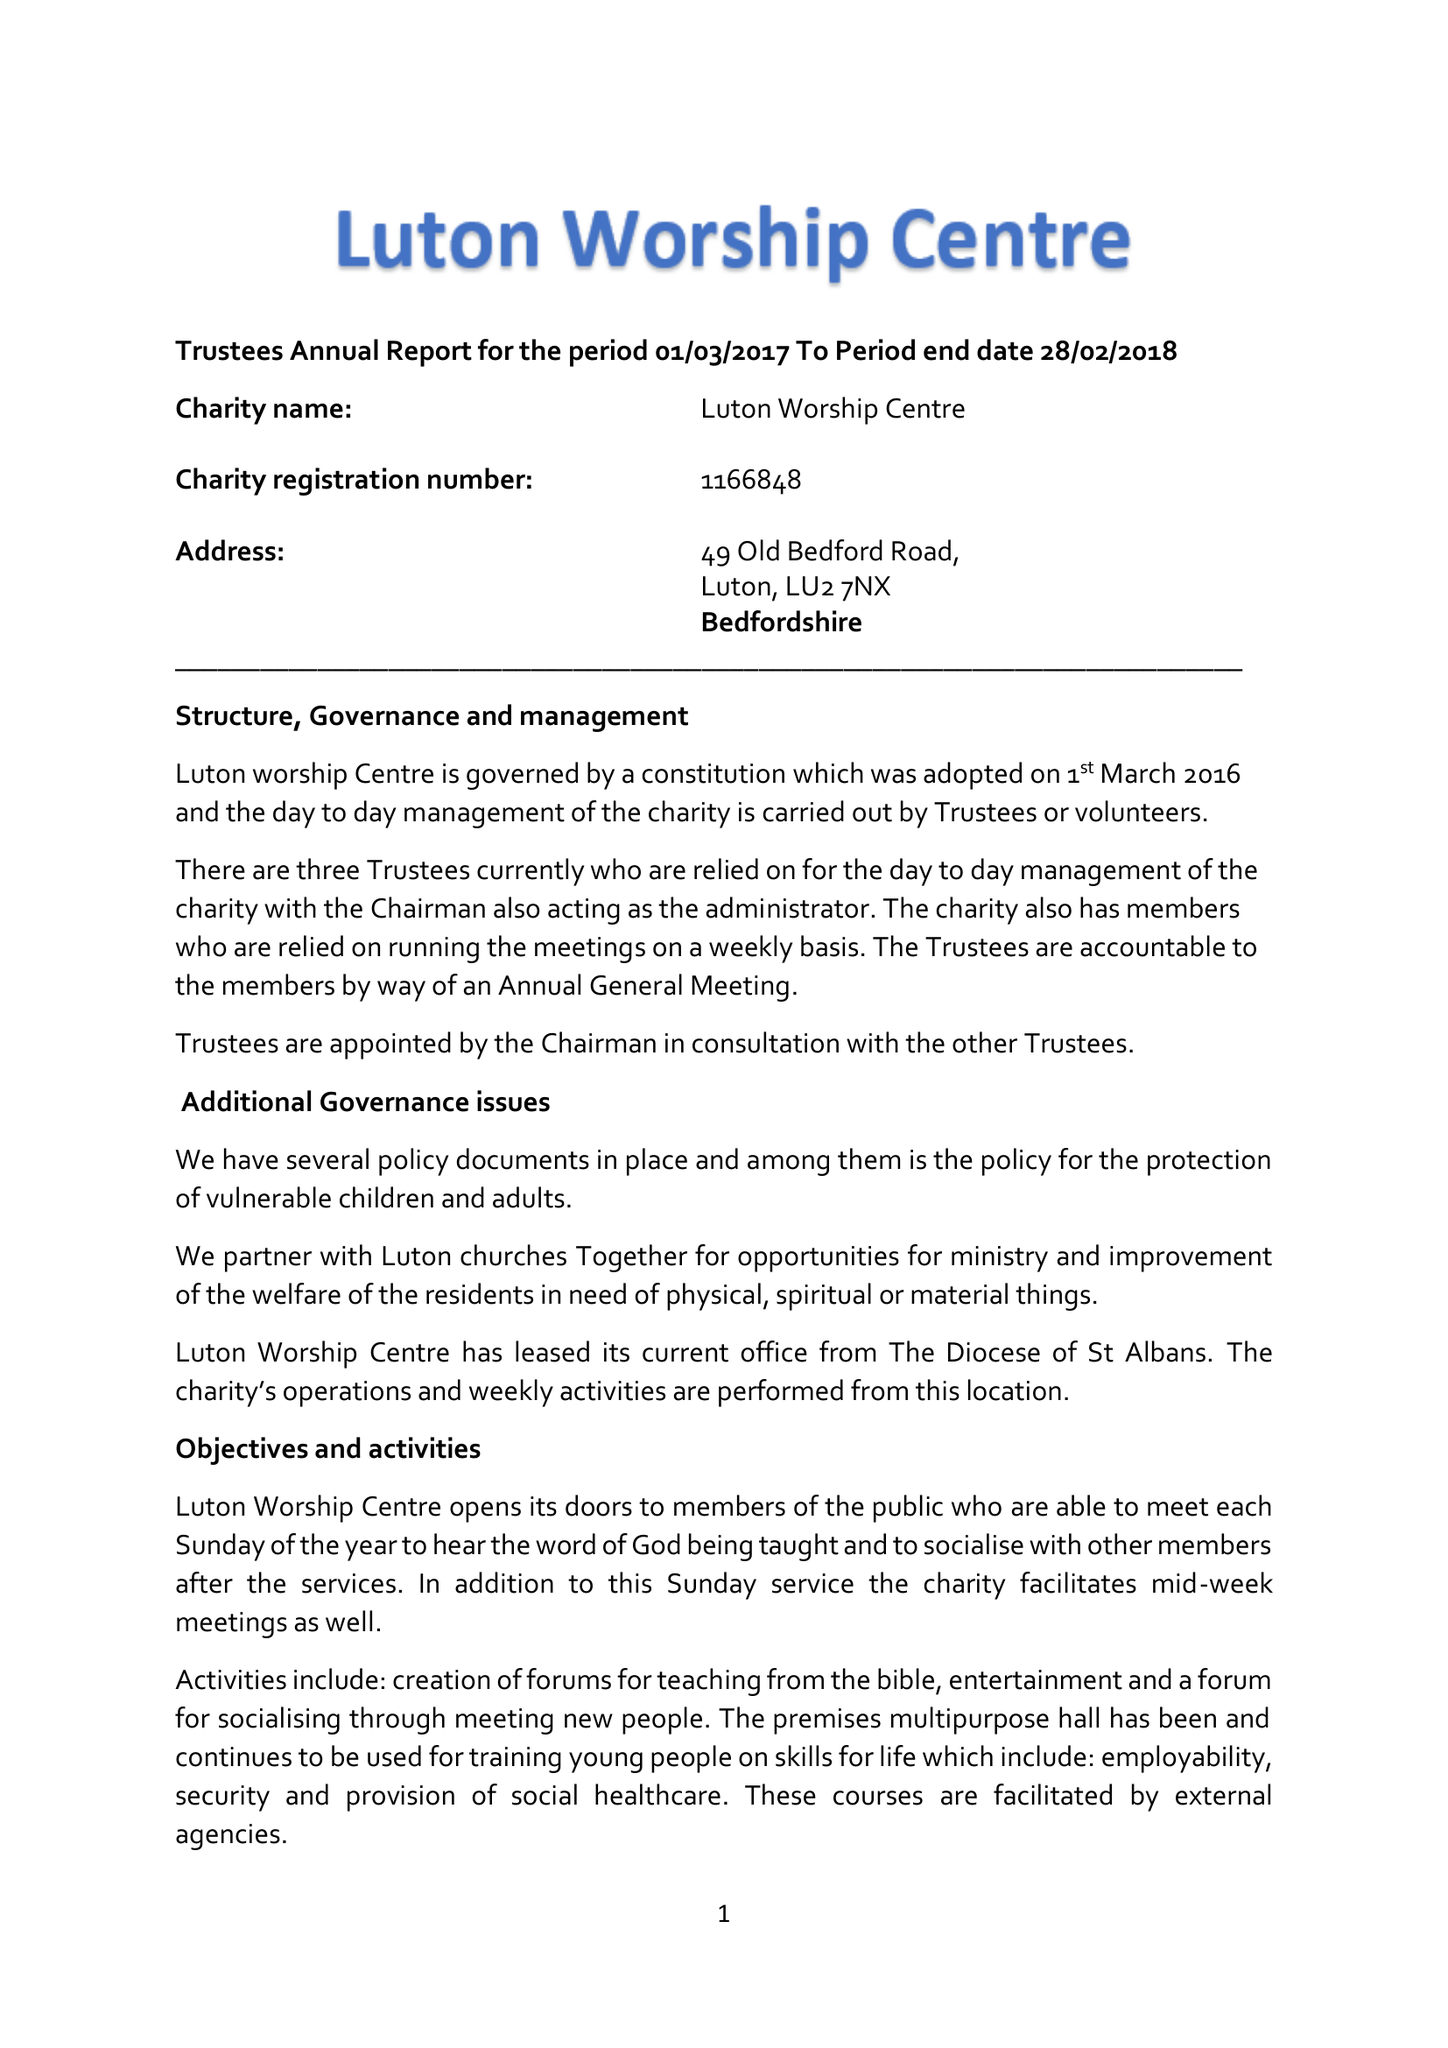What is the value for the income_annually_in_british_pounds?
Answer the question using a single word or phrase. 21897.00 